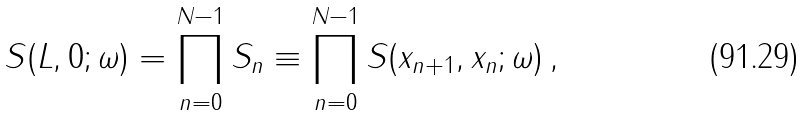<formula> <loc_0><loc_0><loc_500><loc_500>S ( L , 0 ; \omega ) = \prod _ { n = 0 } ^ { N - 1 } S _ { n } \equiv \prod _ { n = 0 } ^ { N - 1 } S ( x _ { n + 1 } , x _ { n } ; \omega ) \, ,</formula> 